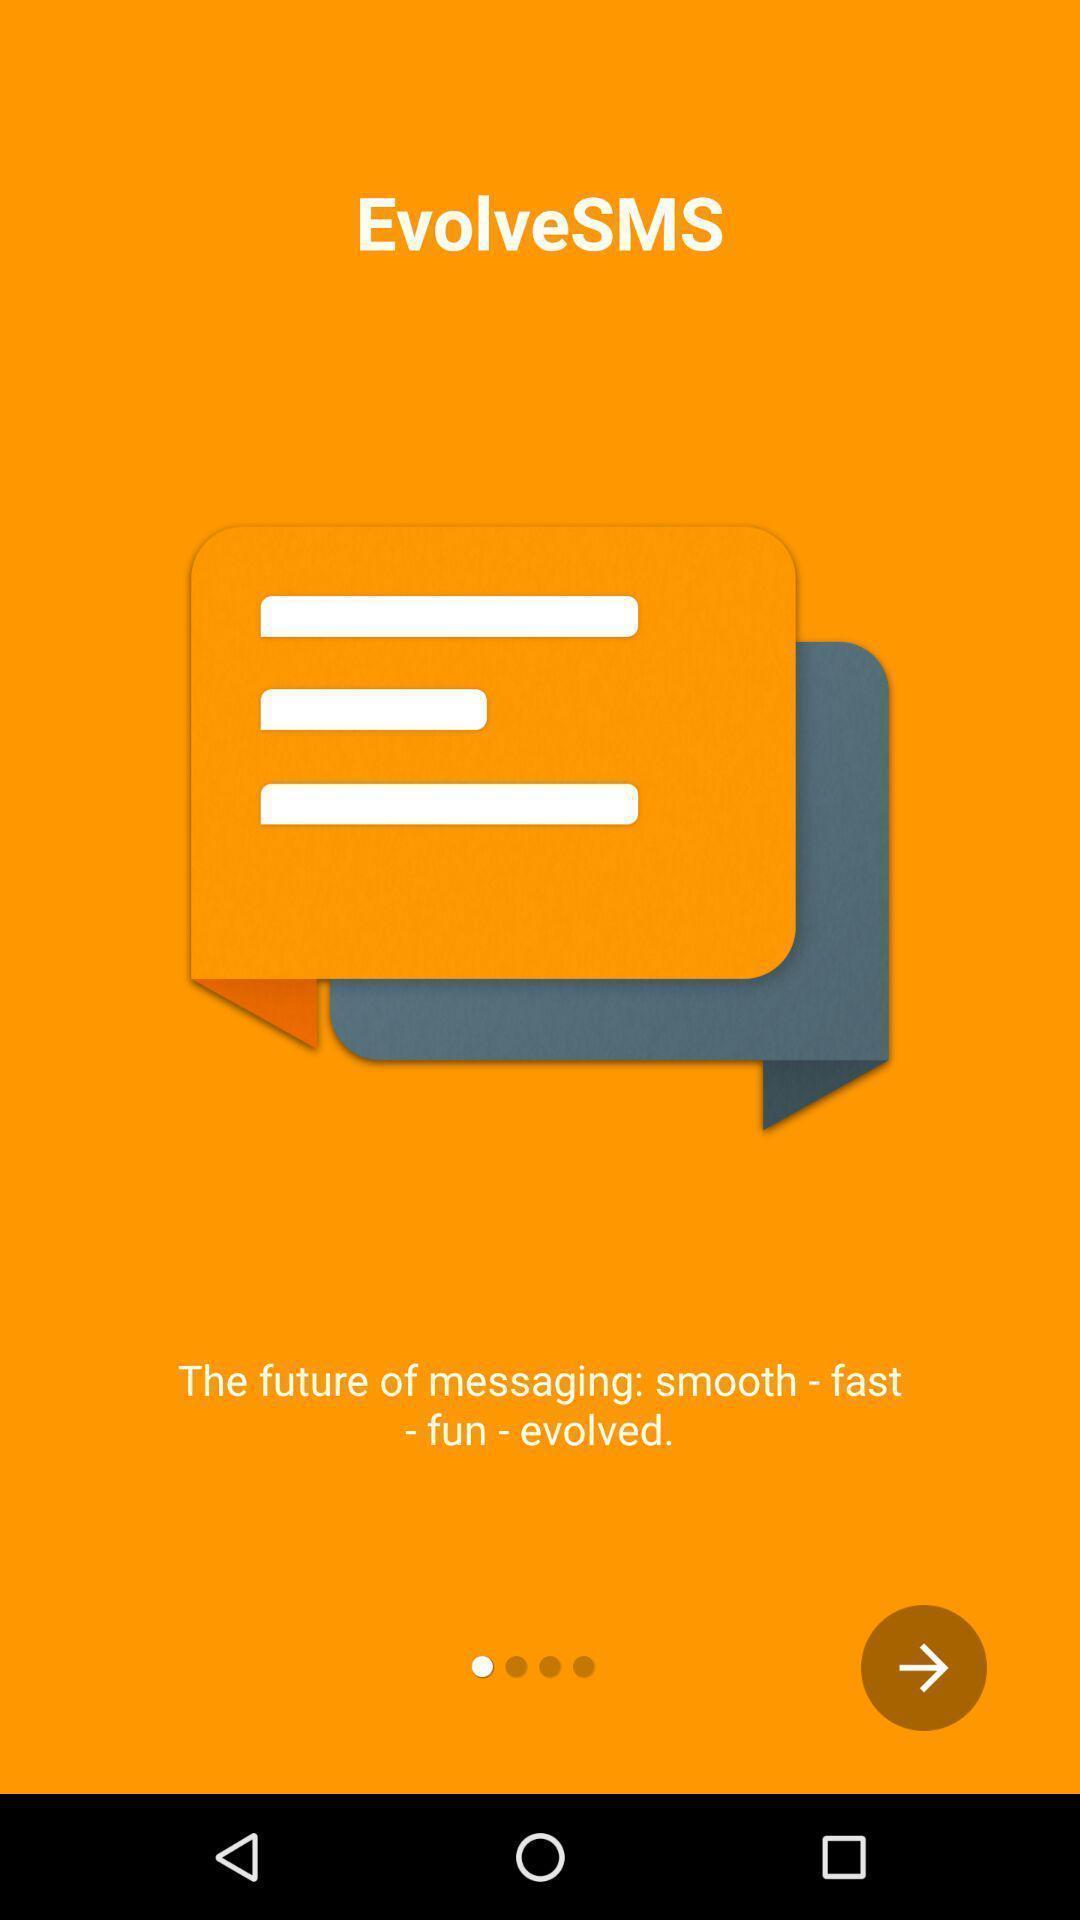Provide a detailed account of this screenshot. Starting page. 